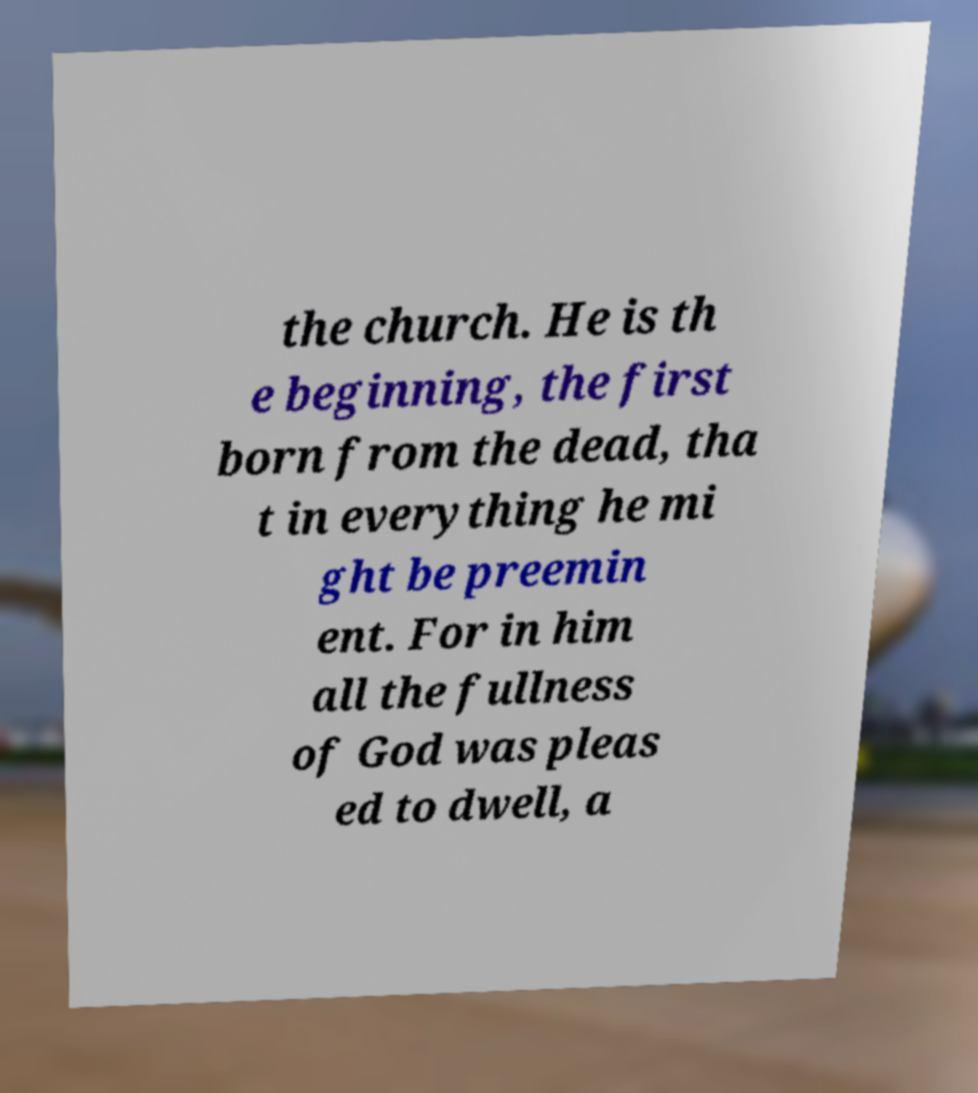Could you assist in decoding the text presented in this image and type it out clearly? the church. He is th e beginning, the first born from the dead, tha t in everything he mi ght be preemin ent. For in him all the fullness of God was pleas ed to dwell, a 